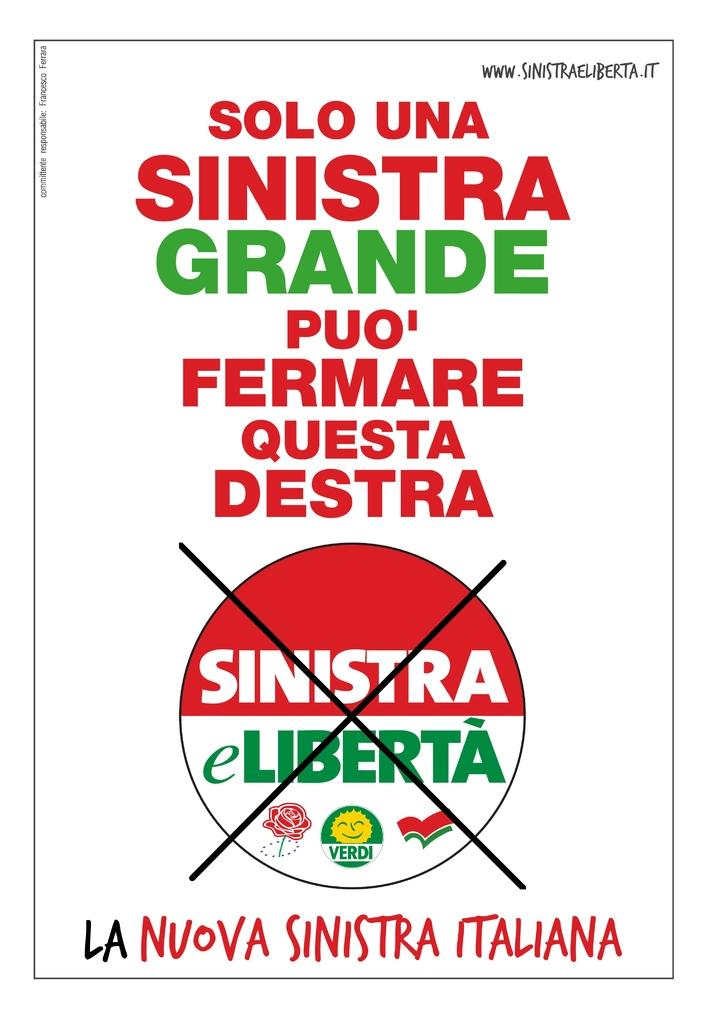<image>
Relay a brief, clear account of the picture shown. An Italian white, red and green protesting poster about liberta, liberty. 